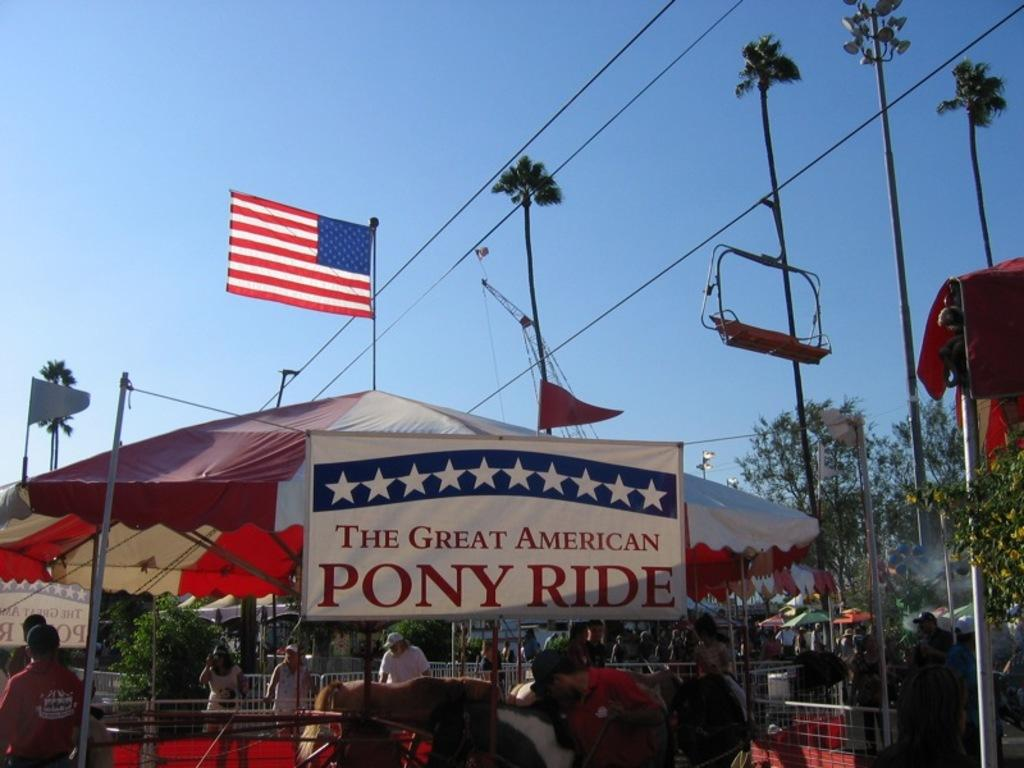What structure is visible in the image? There is a tent in the image. What is attached to the tent? There is a flag above the tent. What type of event is suggested by the image? The scene appears to be a carnival. Who or what else can be seen in the image? There are people and horses in the image. Where are the people and horses located in the image? The people and horses are on the floor. What type of magic trick is being performed with the horses in the image? There is no magic trick being performed with the horses in the image; they are simply on the floor with the people. 